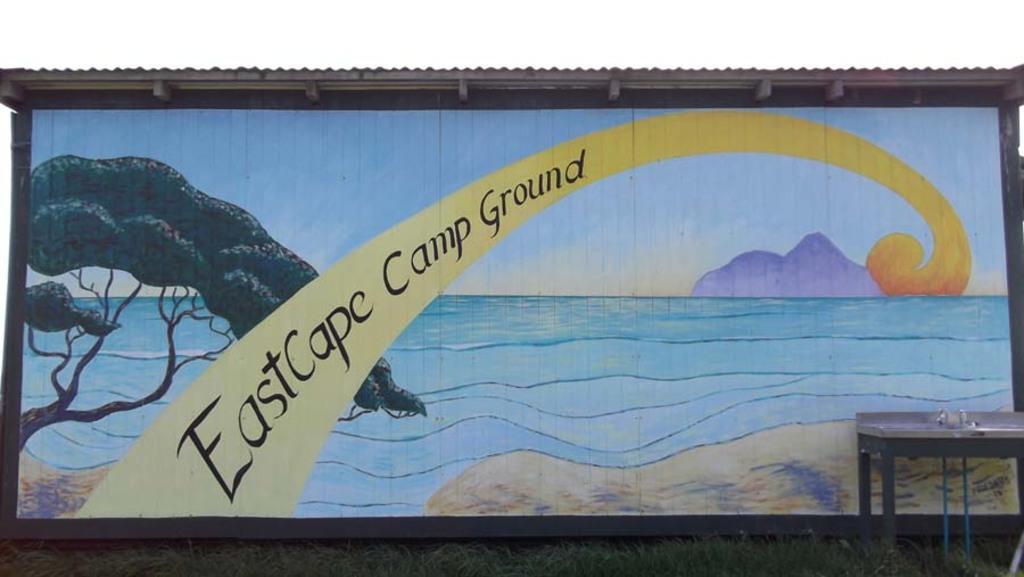In one or two sentences, can you explain what this image depicts? Here in this picture we can see a painting present on a wall and on the right side we can see a table present on the ground, which is fully covered with grass. 